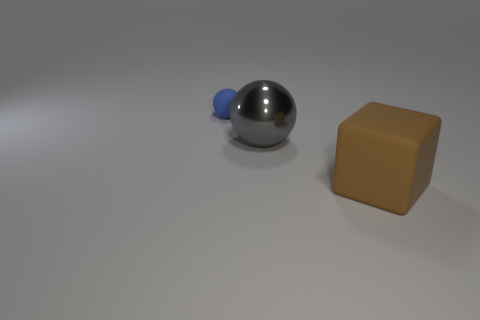Add 1 small red objects. How many objects exist? 4 Subtract all gray metallic objects. Subtract all blue rubber things. How many objects are left? 1 Add 2 big brown cubes. How many big brown cubes are left? 3 Add 2 large rubber blocks. How many large rubber blocks exist? 3 Subtract all blue spheres. How many spheres are left? 1 Subtract 0 brown spheres. How many objects are left? 3 Subtract all cubes. How many objects are left? 2 Subtract 1 blocks. How many blocks are left? 0 Subtract all green blocks. Subtract all yellow cylinders. How many blocks are left? 1 